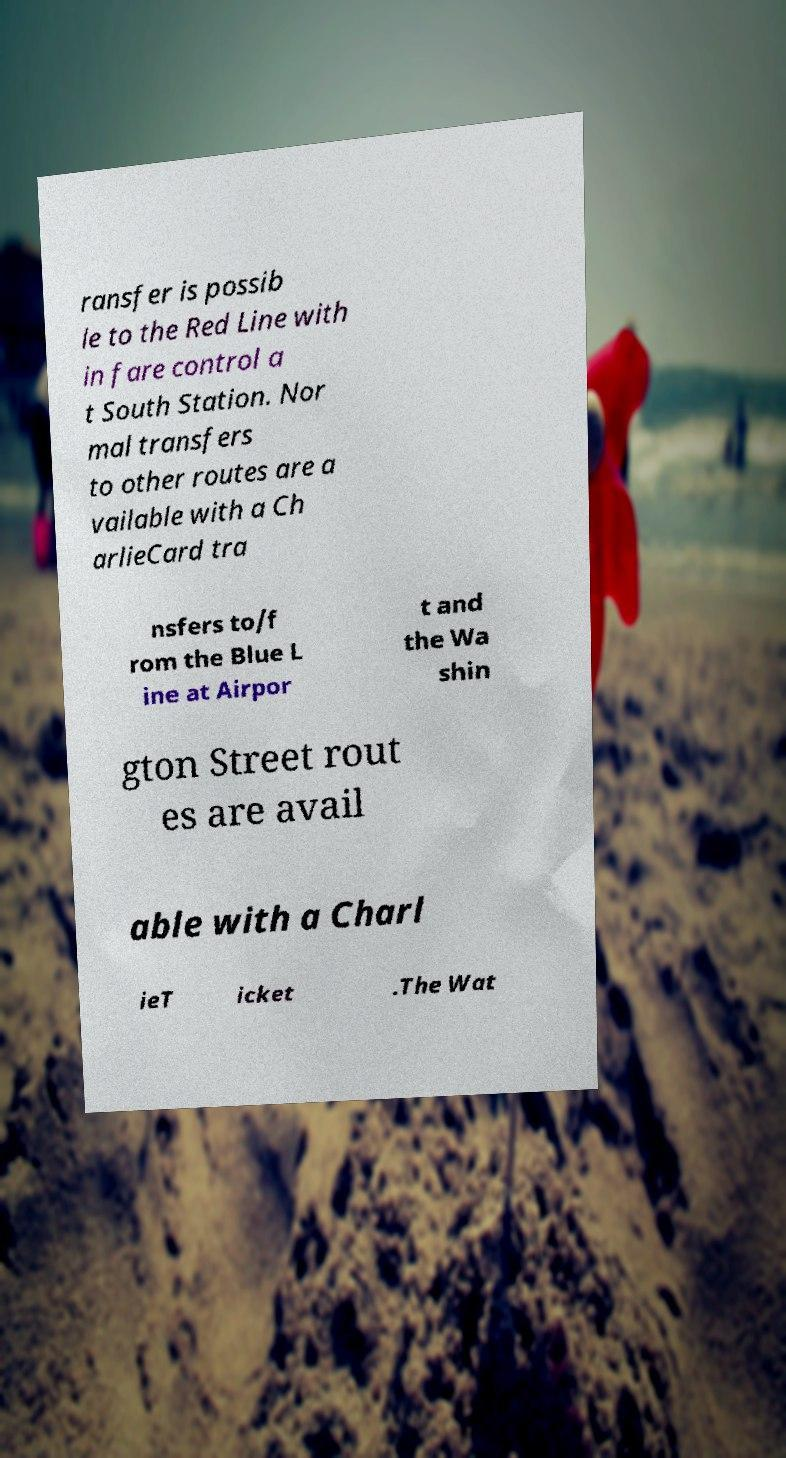There's text embedded in this image that I need extracted. Can you transcribe it verbatim? ransfer is possib le to the Red Line with in fare control a t South Station. Nor mal transfers to other routes are a vailable with a Ch arlieCard tra nsfers to/f rom the Blue L ine at Airpor t and the Wa shin gton Street rout es are avail able with a Charl ieT icket .The Wat 